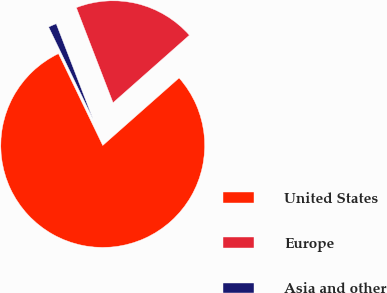Convert chart to OTSL. <chart><loc_0><loc_0><loc_500><loc_500><pie_chart><fcel>United States<fcel>Europe<fcel>Asia and other<nl><fcel>79.37%<fcel>19.34%<fcel>1.29%<nl></chart> 